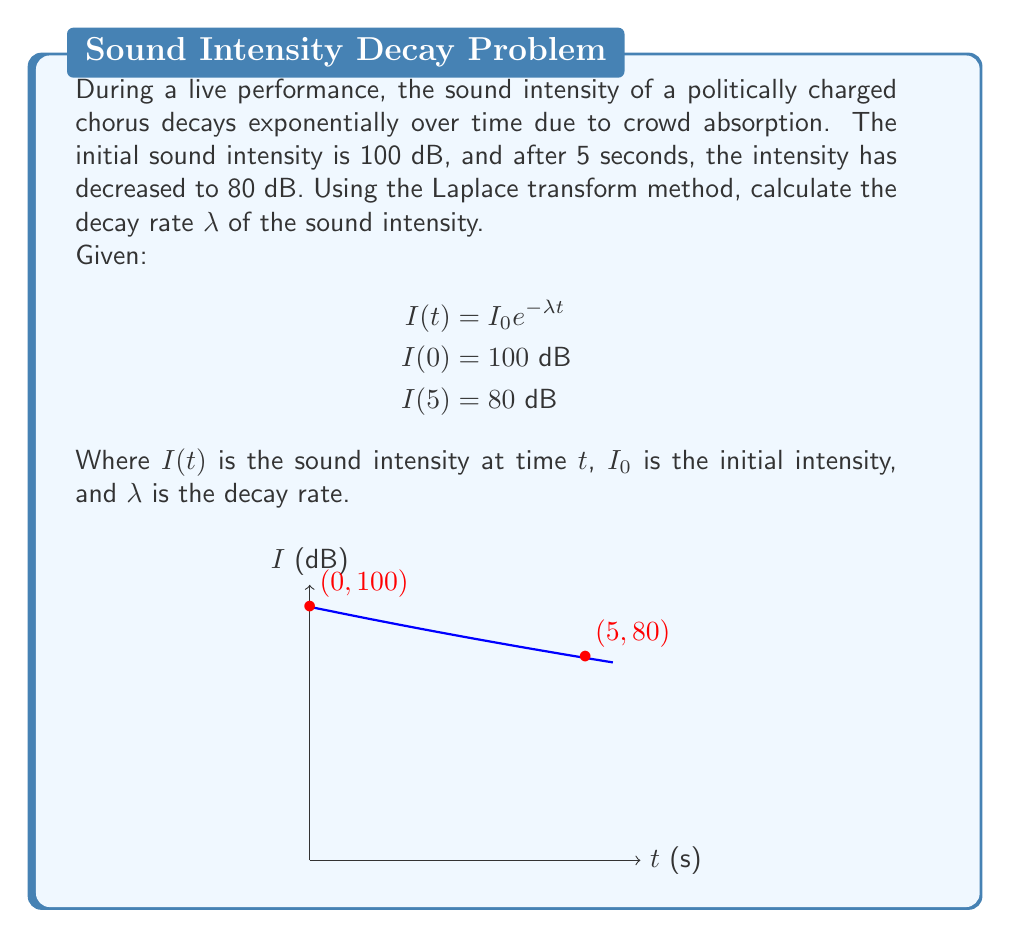Could you help me with this problem? 1) Let's start by taking the Laplace transform of both sides of the equation:
   $$\mathcal{L}\{I(t)\} = \mathcal{L}\{I_0 e^{-λt}\}$$

2) Using the Laplace transform property for exponential functions:
   $$I(s) = I_0 \cdot \frac{1}{s + λ}$$

3) Now, we can use the given conditions to set up an equation:
   $$80 = 100 e^{-5λ}$$

4) Taking the natural logarithm of both sides:
   $$\ln(0.8) = -5λ$$

5) Solving for λ:
   $$λ = -\frac{\ln(0.8)}{5}$$

6) Calculate the value:
   $$λ = -\frac{\ln(0.8)}{5} \approx 0.0446 \text{ s}^{-1}$$

This decay rate λ represents how quickly the sound intensity decreases over time during the performance.
Answer: $λ \approx 0.0446 \text{ s}^{-1}$ 